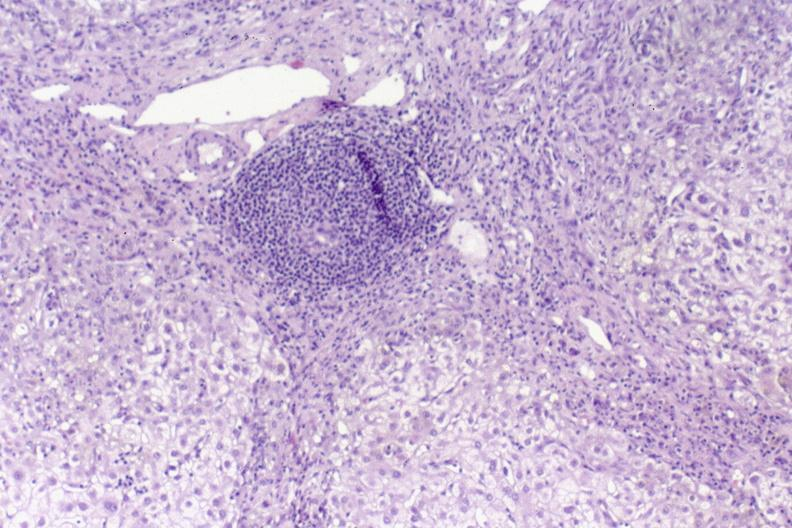what is present?
Answer the question using a single word or phrase. Hepatobiliary 